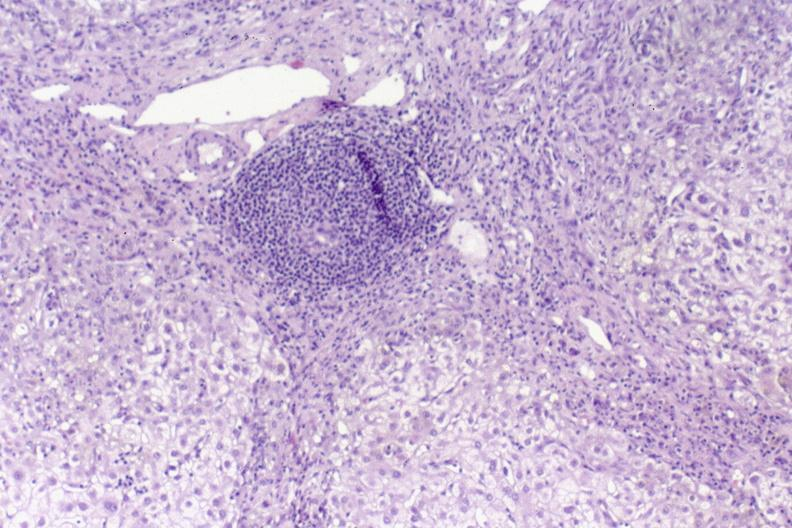what is present?
Answer the question using a single word or phrase. Hepatobiliary 